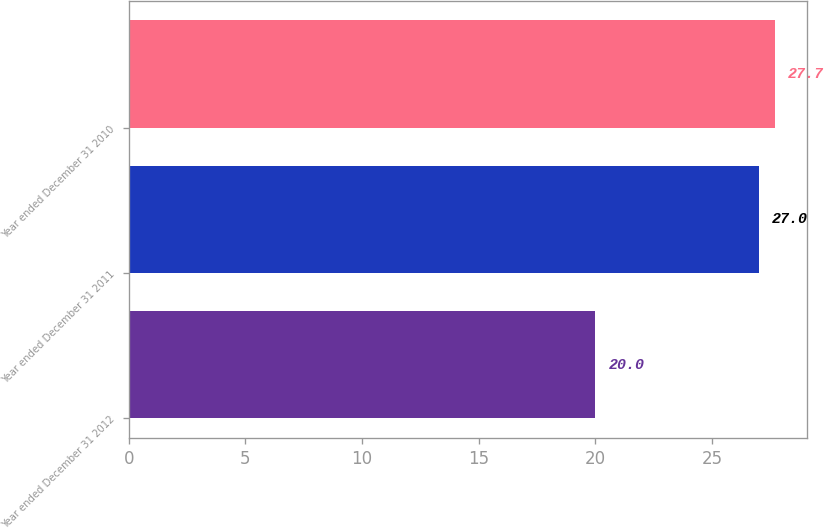Convert chart to OTSL. <chart><loc_0><loc_0><loc_500><loc_500><bar_chart><fcel>Year ended December 31 2012<fcel>Year ended December 31 2011<fcel>Year ended December 31 2010<nl><fcel>20<fcel>27<fcel>27.7<nl></chart> 